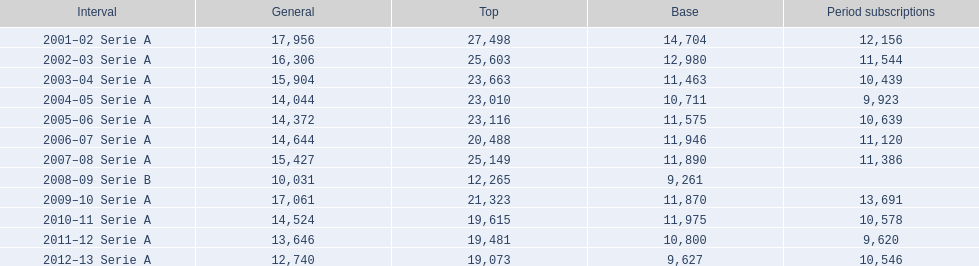What are the seasons? 2001–02 Serie A, 2002–03 Serie A, 2003–04 Serie A, 2004–05 Serie A, 2005–06 Serie A, 2006–07 Serie A, 2007–08 Serie A, 2008–09 Serie B, 2009–10 Serie A, 2010–11 Serie A, 2011–12 Serie A, 2012–13 Serie A. Which season is in 2007? 2007–08 Serie A. How many season tickets were sold that season? 11,386. 